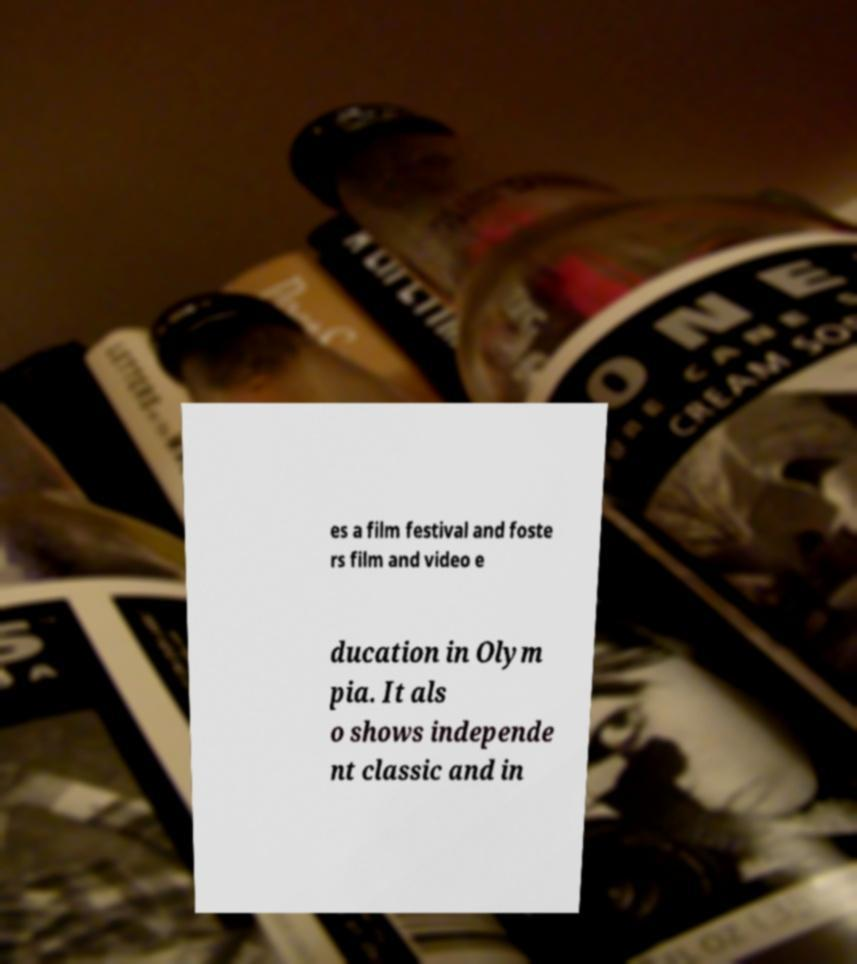I need the written content from this picture converted into text. Can you do that? es a film festival and foste rs film and video e ducation in Olym pia. It als o shows independe nt classic and in 